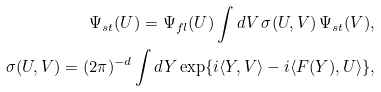<formula> <loc_0><loc_0><loc_500><loc_500>\Psi _ { s t } ( U ) = \Psi _ { f l } ( U ) \int d V \, \sigma ( U , V ) \, \Psi _ { s t } ( V ) , \\ \sigma ( U , V ) = ( 2 \pi ) ^ { - d } \int d Y \exp \{ i \langle Y , V \rangle - i \langle F ( Y ) , U \rangle \} ,</formula> 